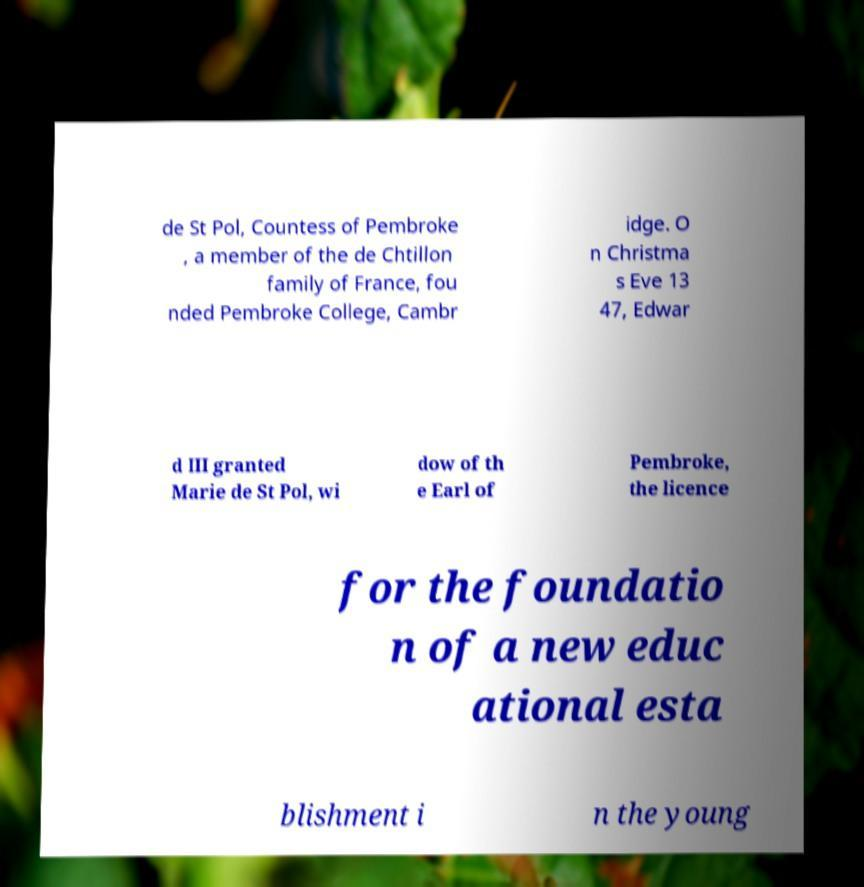Could you extract and type out the text from this image? de St Pol, Countess of Pembroke , a member of the de Chtillon family of France, fou nded Pembroke College, Cambr idge. O n Christma s Eve 13 47, Edwar d III granted Marie de St Pol, wi dow of th e Earl of Pembroke, the licence for the foundatio n of a new educ ational esta blishment i n the young 